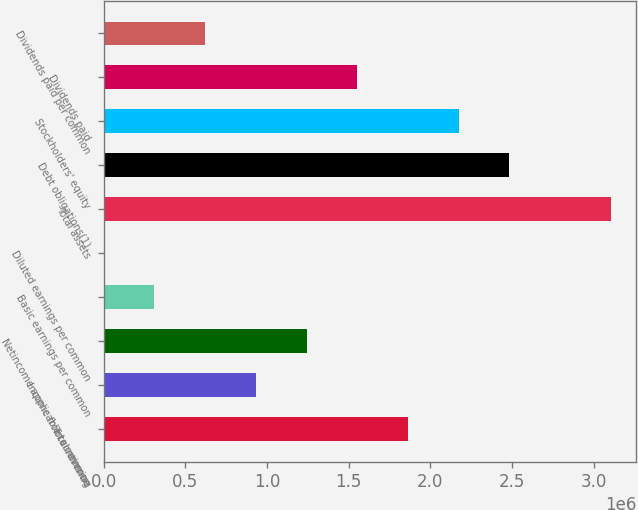Convert chart to OTSL. <chart><loc_0><loc_0><loc_500><loc_500><bar_chart><fcel>Total revenue<fcel>Income from continuing<fcel>Netincome applicable to common<fcel>Basic earnings per common<fcel>Diluted earnings per common<fcel>Total assets<fcel>Debt obligations(1)<fcel>Stockholders' equity<fcel>Dividends paid<fcel>Dividends paid per common<nl><fcel>1.86272e+06<fcel>931358<fcel>1.24181e+06<fcel>310453<fcel>0.7<fcel>3.10453e+06<fcel>2.48362e+06<fcel>2.17317e+06<fcel>1.55226e+06<fcel>620906<nl></chart> 